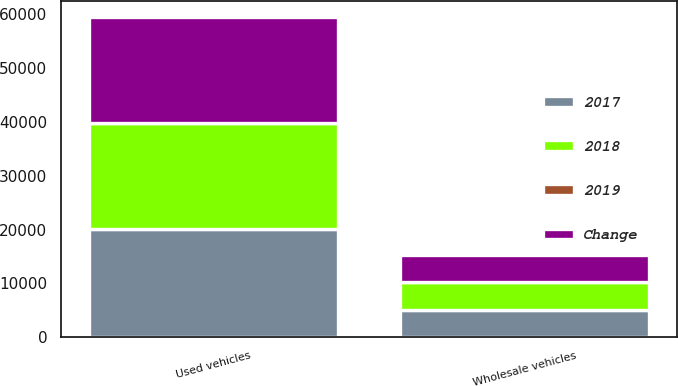Convert chart. <chart><loc_0><loc_0><loc_500><loc_500><stacked_bar_chart><ecel><fcel>Used vehicles<fcel>Wholesale vehicles<nl><fcel>2017<fcel>20077<fcel>5098<nl><fcel>2019<fcel>1.6<fcel>0.1<nl><fcel>2018<fcel>19757<fcel>5102<nl><fcel>Change<fcel>19586<fcel>5106<nl></chart> 